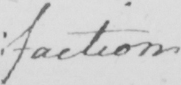What text is written in this handwritten line? : faction 